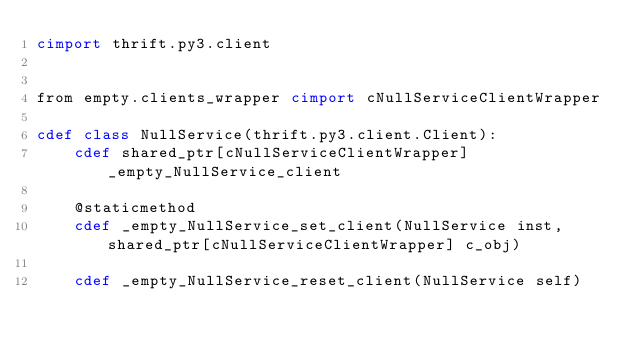<code> <loc_0><loc_0><loc_500><loc_500><_Cython_>cimport thrift.py3.client


from empty.clients_wrapper cimport cNullServiceClientWrapper

cdef class NullService(thrift.py3.client.Client):
    cdef shared_ptr[cNullServiceClientWrapper] _empty_NullService_client

    @staticmethod
    cdef _empty_NullService_set_client(NullService inst, shared_ptr[cNullServiceClientWrapper] c_obj)

    cdef _empty_NullService_reset_client(NullService self)

</code> 